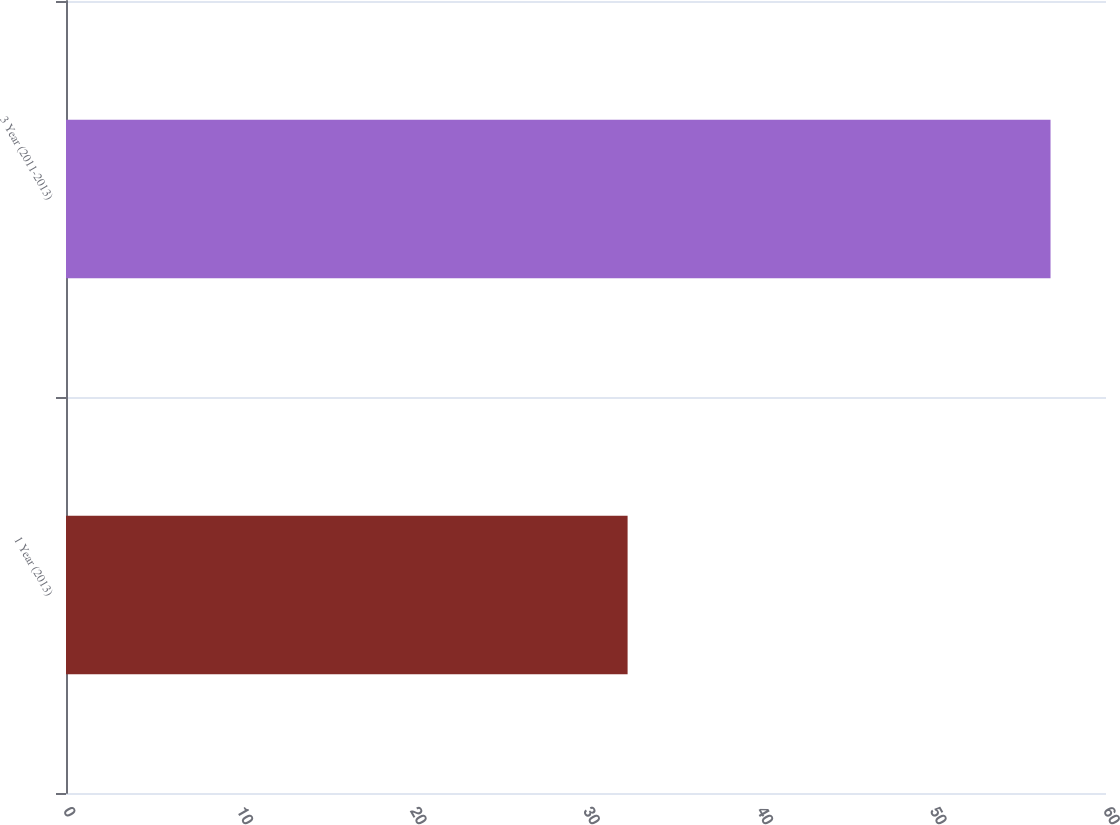Convert chart to OTSL. <chart><loc_0><loc_0><loc_500><loc_500><bar_chart><fcel>1 Year (2013)<fcel>3 Year (2011-2013)<nl><fcel>32.4<fcel>56.8<nl></chart> 